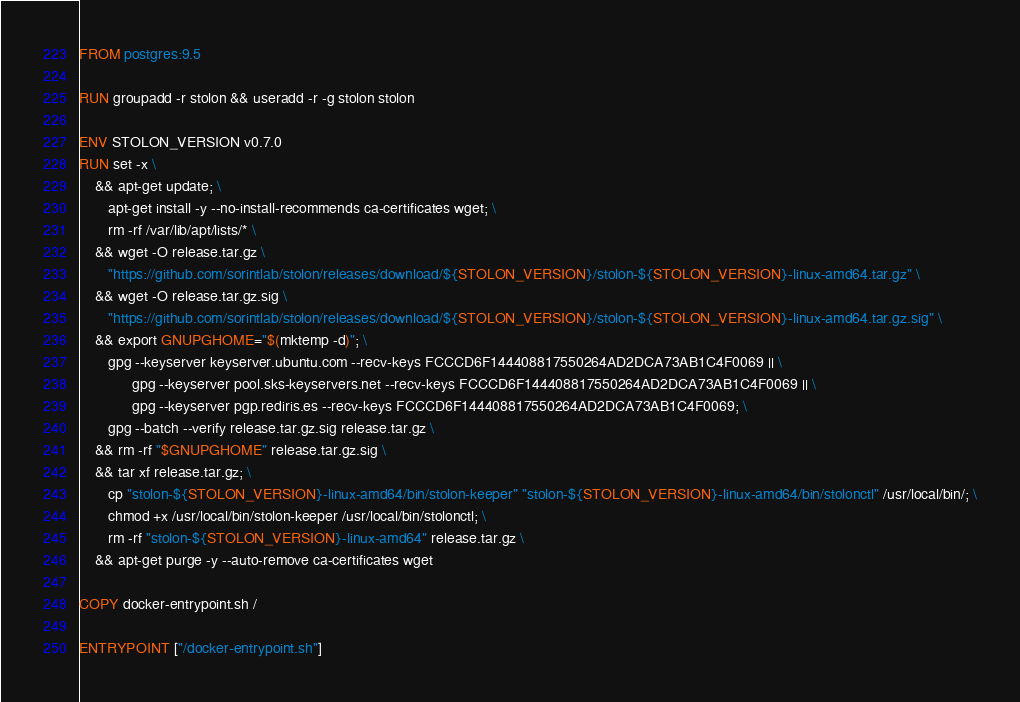<code> <loc_0><loc_0><loc_500><loc_500><_Dockerfile_>FROM postgres:9.5

RUN groupadd -r stolon && useradd -r -g stolon stolon

ENV STOLON_VERSION v0.7.0
RUN set -x \
    && apt-get update; \
       apt-get install -y --no-install-recommends ca-certificates wget; \
       rm -rf /var/lib/apt/lists/* \
    && wget -O release.tar.gz \
       "https://github.com/sorintlab/stolon/releases/download/${STOLON_VERSION}/stolon-${STOLON_VERSION}-linux-amd64.tar.gz" \
    && wget -O release.tar.gz.sig \
       "https://github.com/sorintlab/stolon/releases/download/${STOLON_VERSION}/stolon-${STOLON_VERSION}-linux-amd64.tar.gz.sig" \
    && export GNUPGHOME="$(mktemp -d)"; \
       gpg --keyserver keyserver.ubuntu.com --recv-keys FCCCD6F144408817550264AD2DCA73AB1C4F0069 || \
			 gpg --keyserver pool.sks-keyservers.net --recv-keys FCCCD6F144408817550264AD2DCA73AB1C4F0069 || \
			 gpg --keyserver pgp.rediris.es --recv-keys FCCCD6F144408817550264AD2DCA73AB1C4F0069; \
       gpg --batch --verify release.tar.gz.sig release.tar.gz \
    && rm -rf "$GNUPGHOME" release.tar.gz.sig \
    && tar xf release.tar.gz; \
       cp "stolon-${STOLON_VERSION}-linux-amd64/bin/stolon-keeper" "stolon-${STOLON_VERSION}-linux-amd64/bin/stolonctl" /usr/local/bin/; \
       chmod +x /usr/local/bin/stolon-keeper /usr/local/bin/stolonctl; \
       rm -rf "stolon-${STOLON_VERSION}-linux-amd64" release.tar.gz \
    && apt-get purge -y --auto-remove ca-certificates wget

COPY docker-entrypoint.sh /

ENTRYPOINT ["/docker-entrypoint.sh"]
</code> 